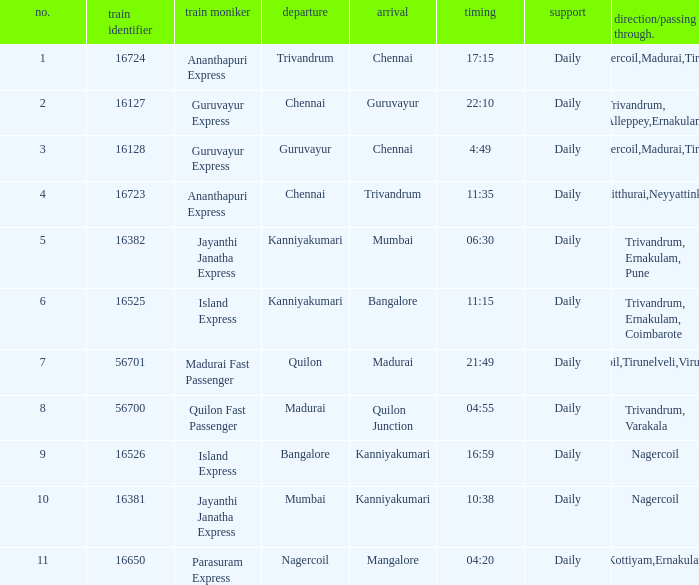What is the route/via when the train name is Parasuram Express? Trivandrum,Kottiyam,Ernakulam,Kozhikode. 